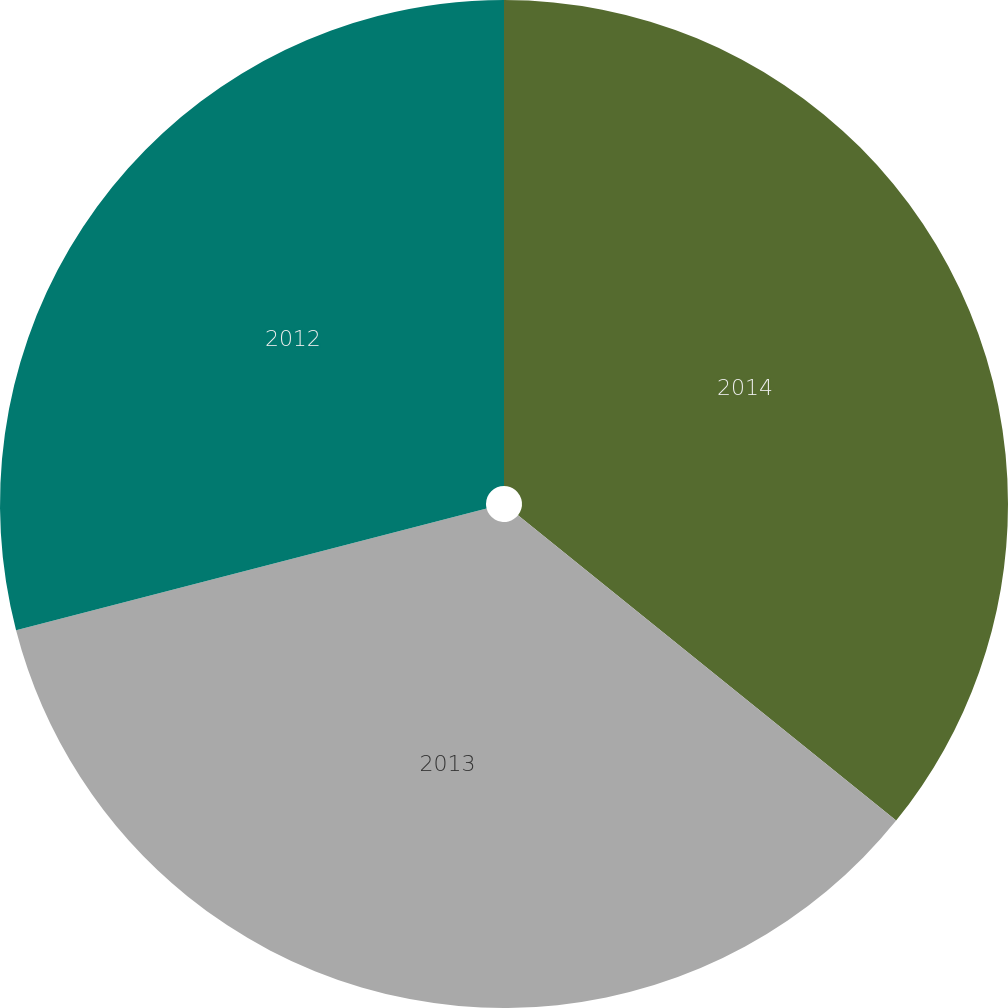<chart> <loc_0><loc_0><loc_500><loc_500><pie_chart><fcel>2014<fcel>2013<fcel>2012<nl><fcel>35.81%<fcel>35.16%<fcel>29.03%<nl></chart> 